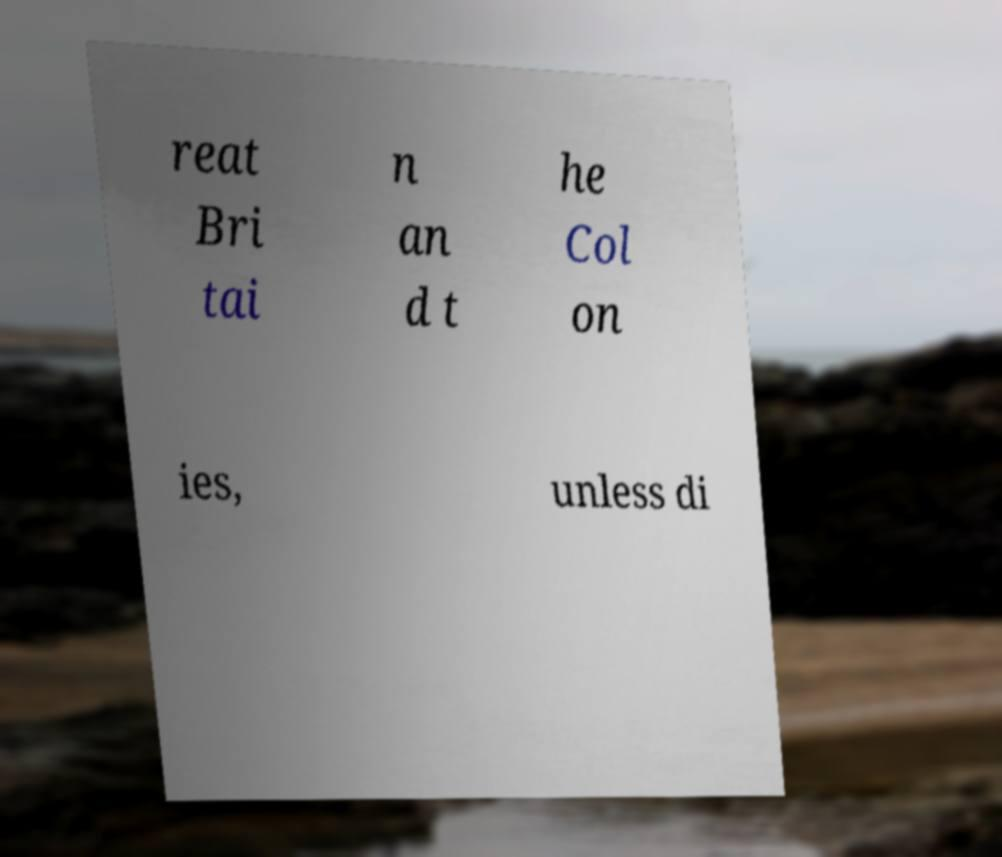There's text embedded in this image that I need extracted. Can you transcribe it verbatim? reat Bri tai n an d t he Col on ies, unless di 